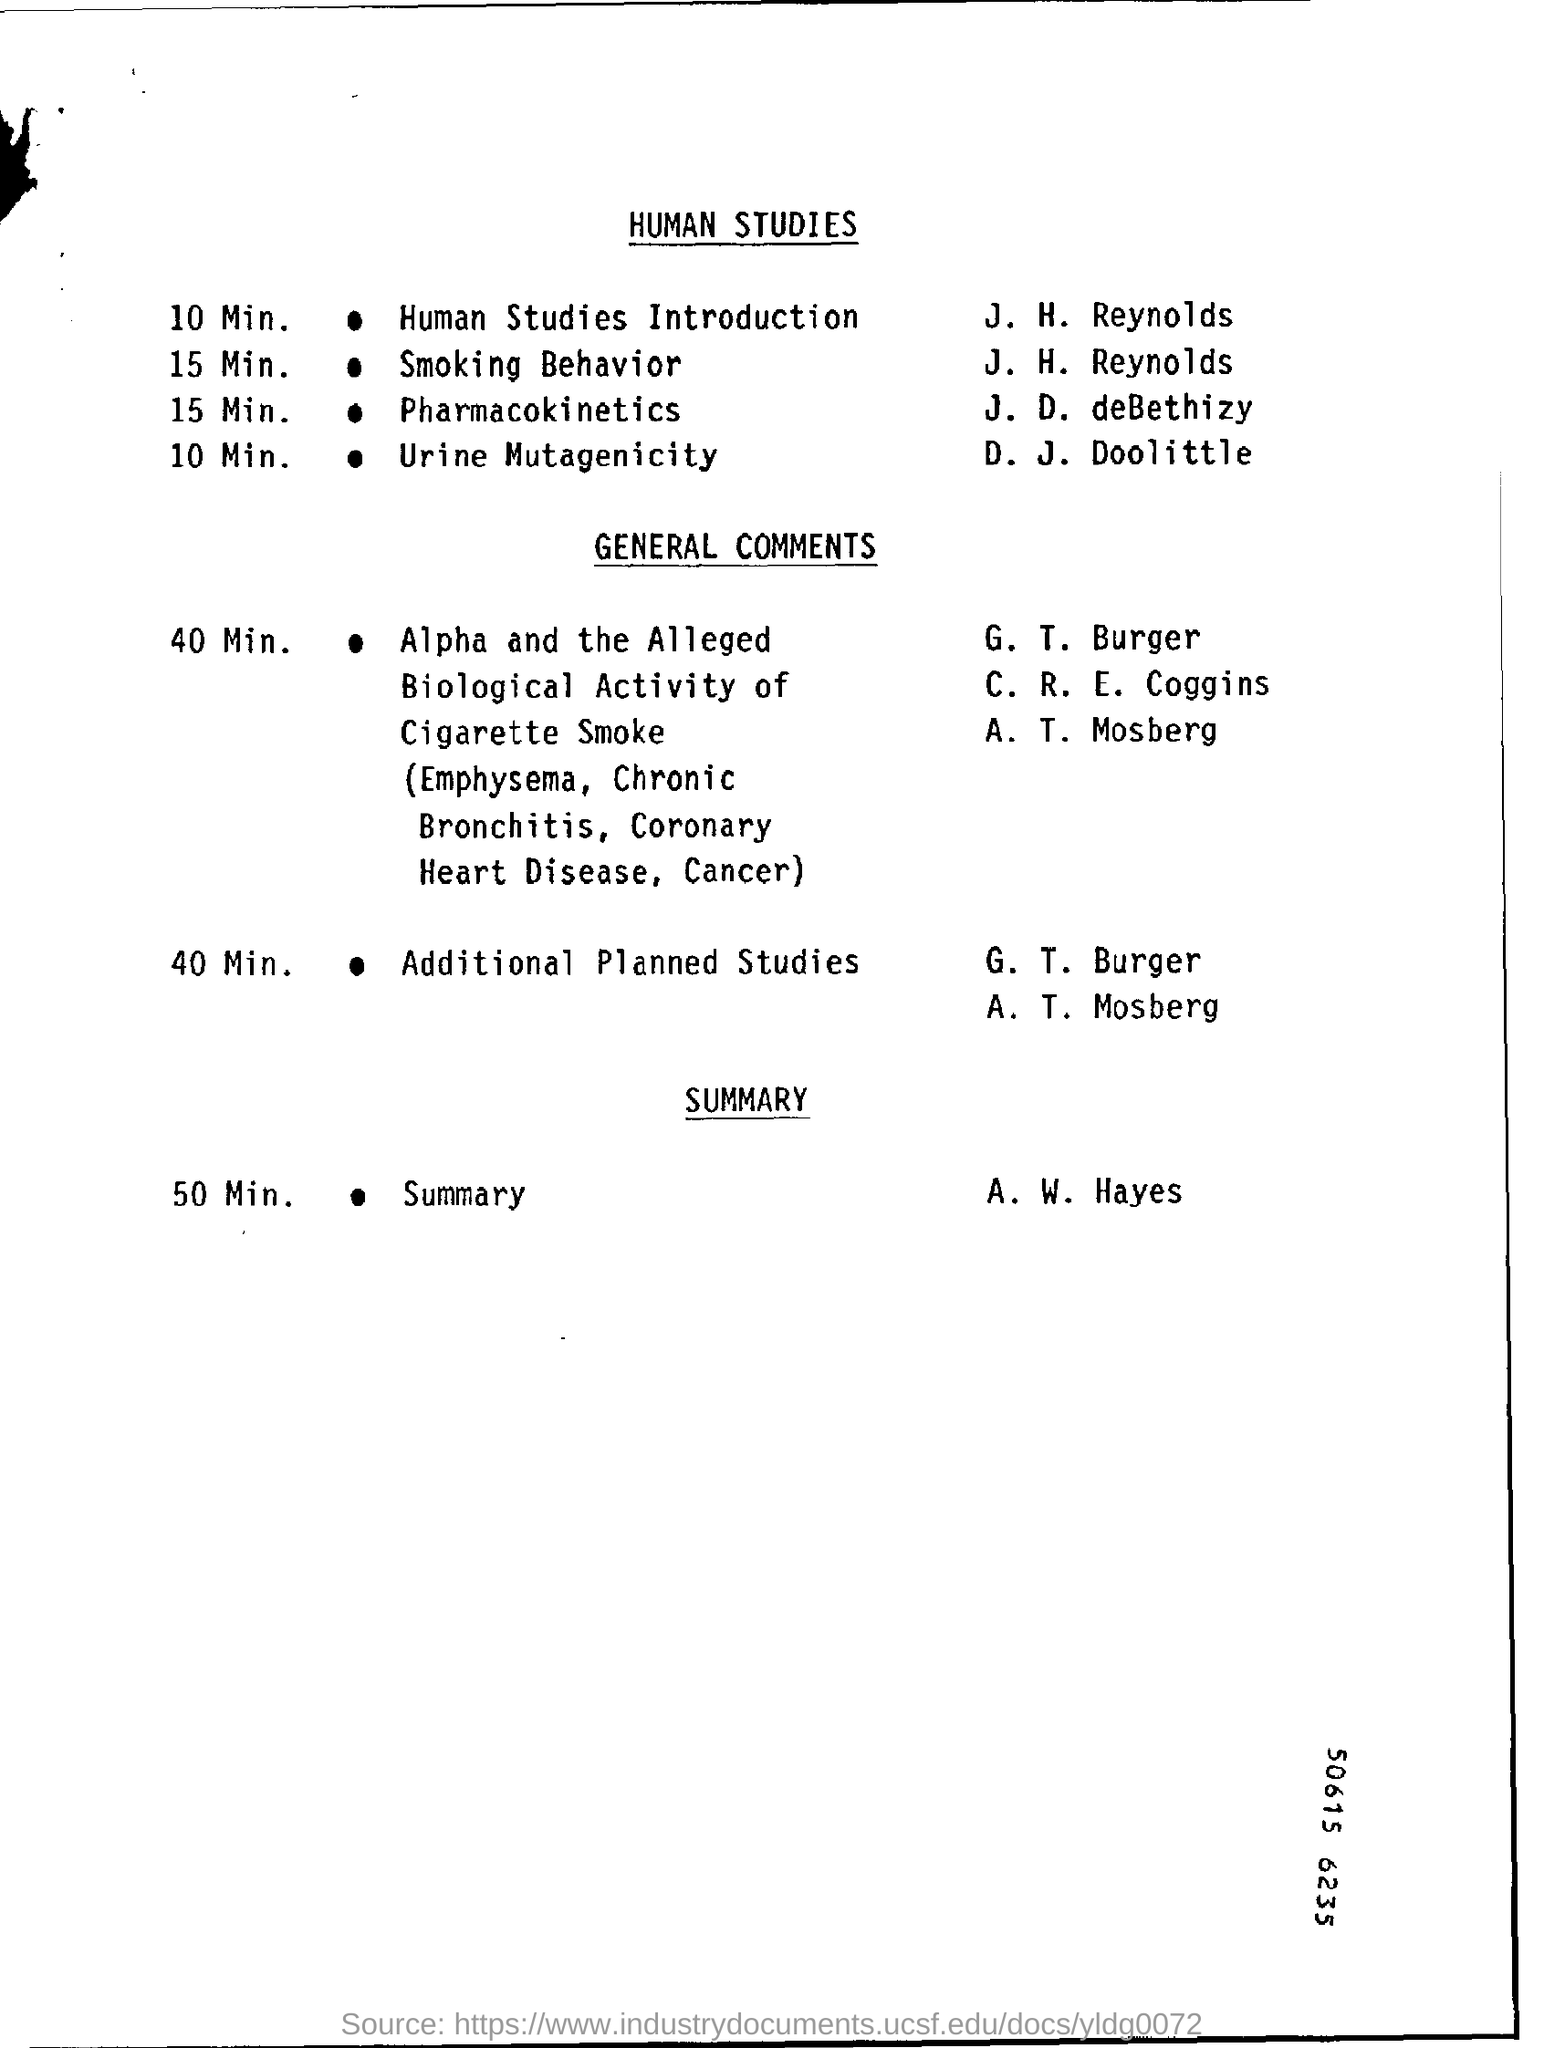What is the duration for Human studies introduction?
Ensure brevity in your answer.  10 min. Who will present human studies introduction?
Provide a succinct answer. J. H. Reynolds. What topic will d. j. doolittle explain?
Your answer should be compact. Urine Mutagenicity. By whom will be the summary presented?
Provide a short and direct response. A. W. Hayes. 